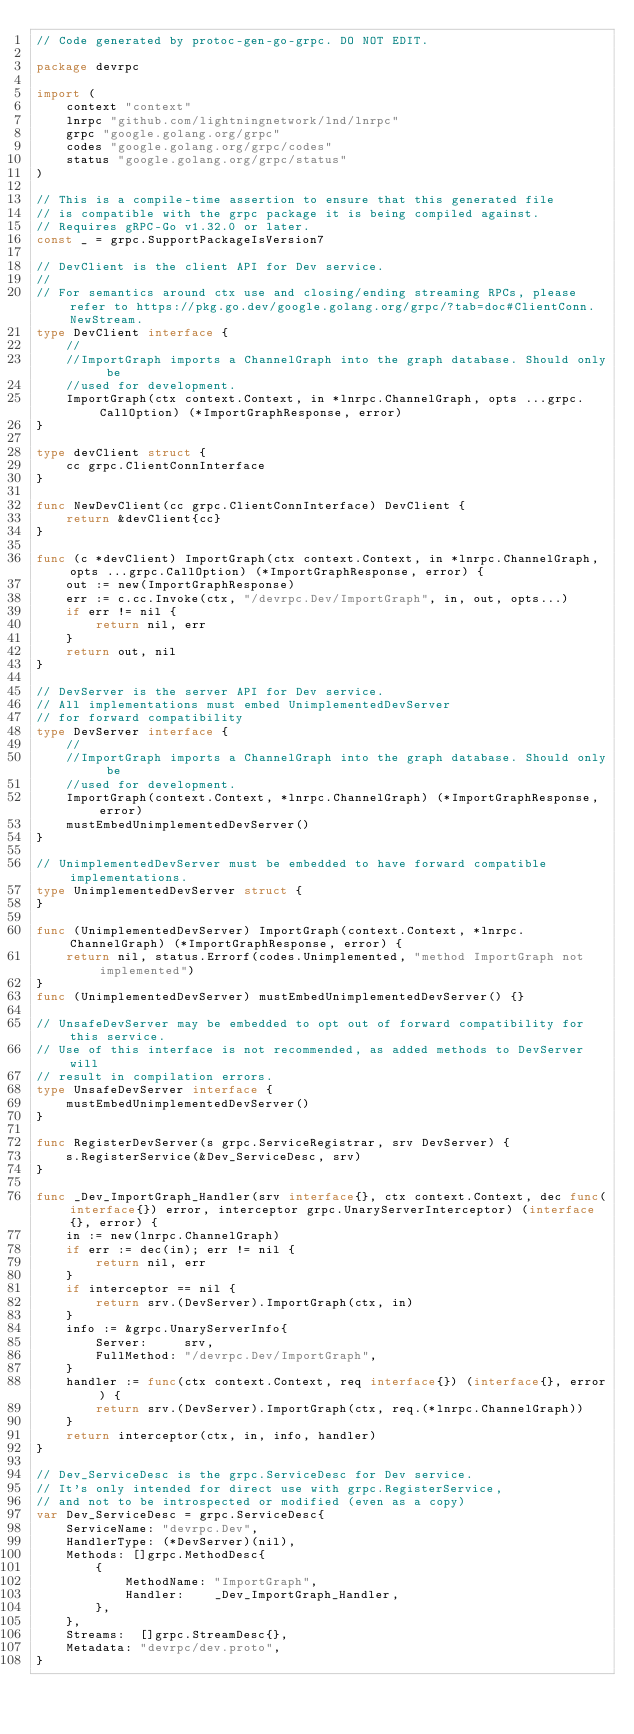<code> <loc_0><loc_0><loc_500><loc_500><_Go_>// Code generated by protoc-gen-go-grpc. DO NOT EDIT.

package devrpc

import (
	context "context"
	lnrpc "github.com/lightningnetwork/lnd/lnrpc"
	grpc "google.golang.org/grpc"
	codes "google.golang.org/grpc/codes"
	status "google.golang.org/grpc/status"
)

// This is a compile-time assertion to ensure that this generated file
// is compatible with the grpc package it is being compiled against.
// Requires gRPC-Go v1.32.0 or later.
const _ = grpc.SupportPackageIsVersion7

// DevClient is the client API for Dev service.
//
// For semantics around ctx use and closing/ending streaming RPCs, please refer to https://pkg.go.dev/google.golang.org/grpc/?tab=doc#ClientConn.NewStream.
type DevClient interface {
	//
	//ImportGraph imports a ChannelGraph into the graph database. Should only be
	//used for development.
	ImportGraph(ctx context.Context, in *lnrpc.ChannelGraph, opts ...grpc.CallOption) (*ImportGraphResponse, error)
}

type devClient struct {
	cc grpc.ClientConnInterface
}

func NewDevClient(cc grpc.ClientConnInterface) DevClient {
	return &devClient{cc}
}

func (c *devClient) ImportGraph(ctx context.Context, in *lnrpc.ChannelGraph, opts ...grpc.CallOption) (*ImportGraphResponse, error) {
	out := new(ImportGraphResponse)
	err := c.cc.Invoke(ctx, "/devrpc.Dev/ImportGraph", in, out, opts...)
	if err != nil {
		return nil, err
	}
	return out, nil
}

// DevServer is the server API for Dev service.
// All implementations must embed UnimplementedDevServer
// for forward compatibility
type DevServer interface {
	//
	//ImportGraph imports a ChannelGraph into the graph database. Should only be
	//used for development.
	ImportGraph(context.Context, *lnrpc.ChannelGraph) (*ImportGraphResponse, error)
	mustEmbedUnimplementedDevServer()
}

// UnimplementedDevServer must be embedded to have forward compatible implementations.
type UnimplementedDevServer struct {
}

func (UnimplementedDevServer) ImportGraph(context.Context, *lnrpc.ChannelGraph) (*ImportGraphResponse, error) {
	return nil, status.Errorf(codes.Unimplemented, "method ImportGraph not implemented")
}
func (UnimplementedDevServer) mustEmbedUnimplementedDevServer() {}

// UnsafeDevServer may be embedded to opt out of forward compatibility for this service.
// Use of this interface is not recommended, as added methods to DevServer will
// result in compilation errors.
type UnsafeDevServer interface {
	mustEmbedUnimplementedDevServer()
}

func RegisterDevServer(s grpc.ServiceRegistrar, srv DevServer) {
	s.RegisterService(&Dev_ServiceDesc, srv)
}

func _Dev_ImportGraph_Handler(srv interface{}, ctx context.Context, dec func(interface{}) error, interceptor grpc.UnaryServerInterceptor) (interface{}, error) {
	in := new(lnrpc.ChannelGraph)
	if err := dec(in); err != nil {
		return nil, err
	}
	if interceptor == nil {
		return srv.(DevServer).ImportGraph(ctx, in)
	}
	info := &grpc.UnaryServerInfo{
		Server:     srv,
		FullMethod: "/devrpc.Dev/ImportGraph",
	}
	handler := func(ctx context.Context, req interface{}) (interface{}, error) {
		return srv.(DevServer).ImportGraph(ctx, req.(*lnrpc.ChannelGraph))
	}
	return interceptor(ctx, in, info, handler)
}

// Dev_ServiceDesc is the grpc.ServiceDesc for Dev service.
// It's only intended for direct use with grpc.RegisterService,
// and not to be introspected or modified (even as a copy)
var Dev_ServiceDesc = grpc.ServiceDesc{
	ServiceName: "devrpc.Dev",
	HandlerType: (*DevServer)(nil),
	Methods: []grpc.MethodDesc{
		{
			MethodName: "ImportGraph",
			Handler:    _Dev_ImportGraph_Handler,
		},
	},
	Streams:  []grpc.StreamDesc{},
	Metadata: "devrpc/dev.proto",
}
</code> 